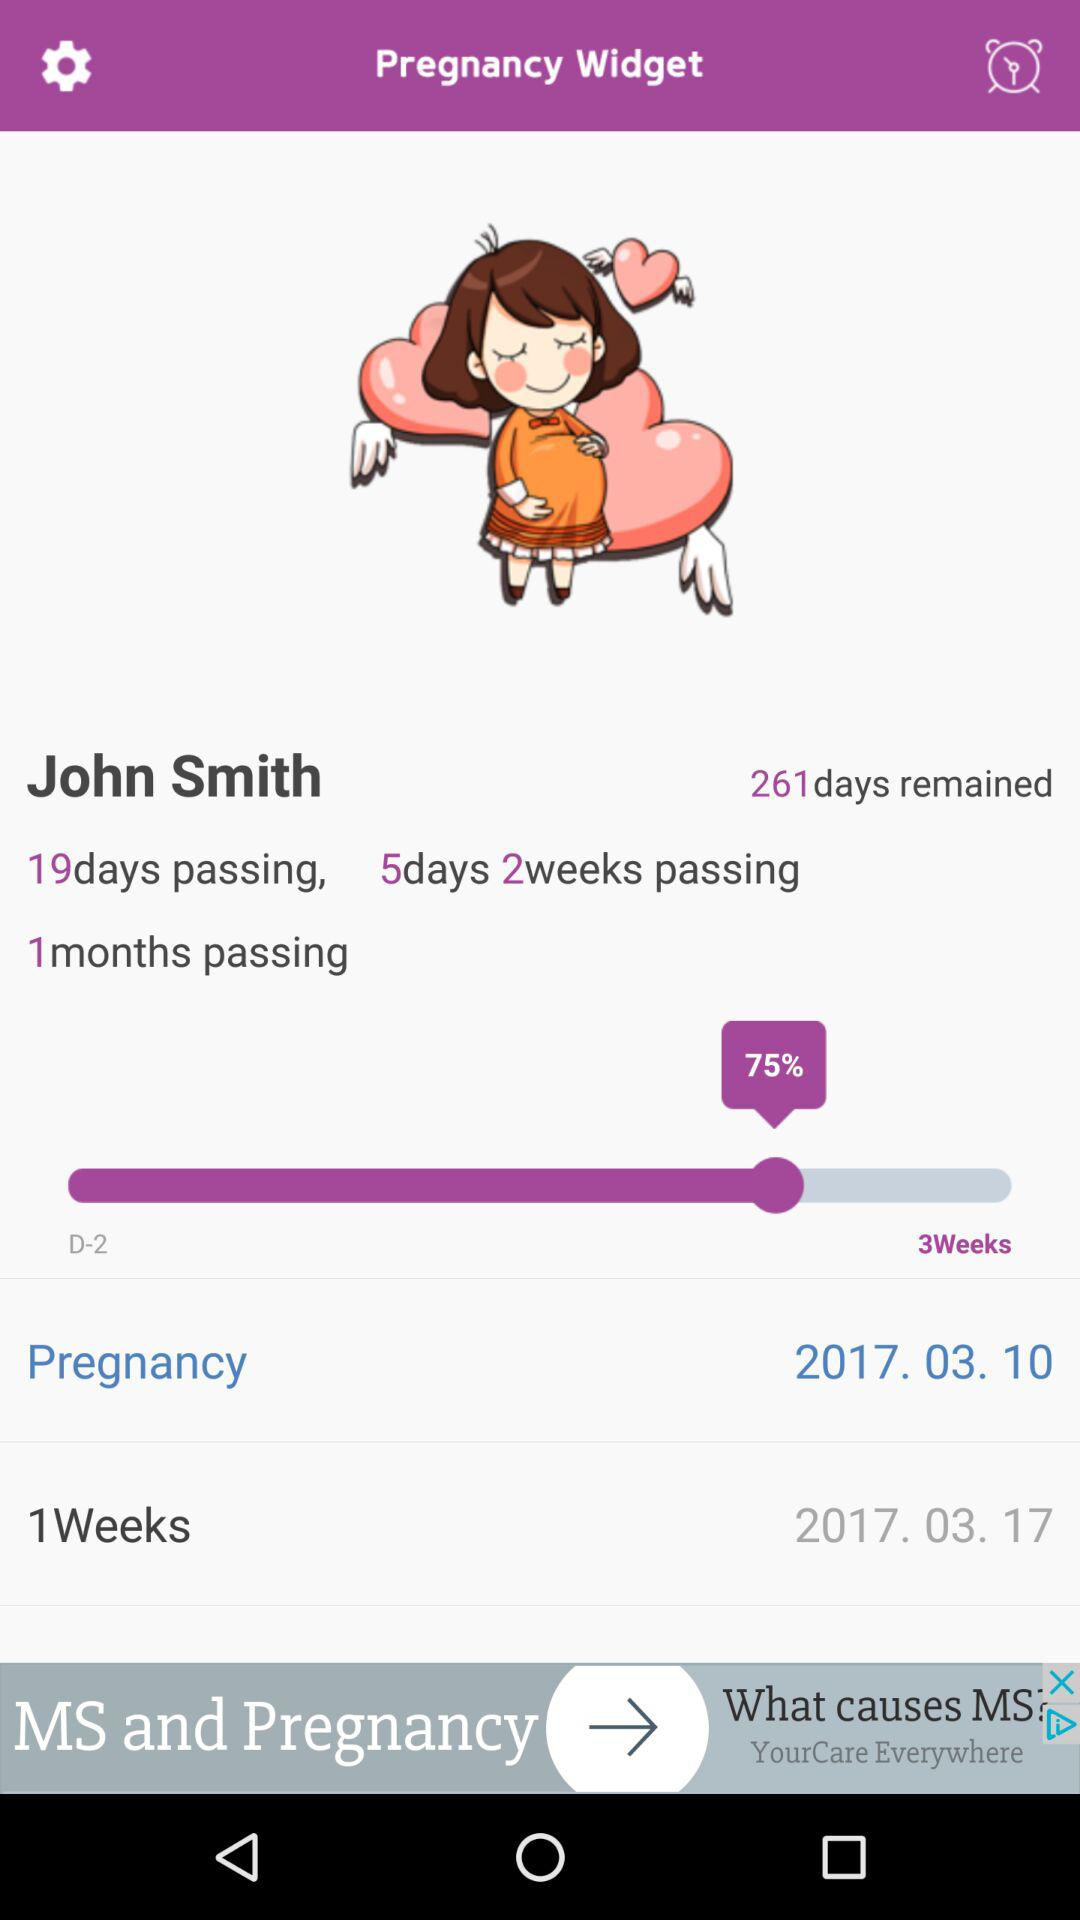How many days have passed? There have been 19 days. 